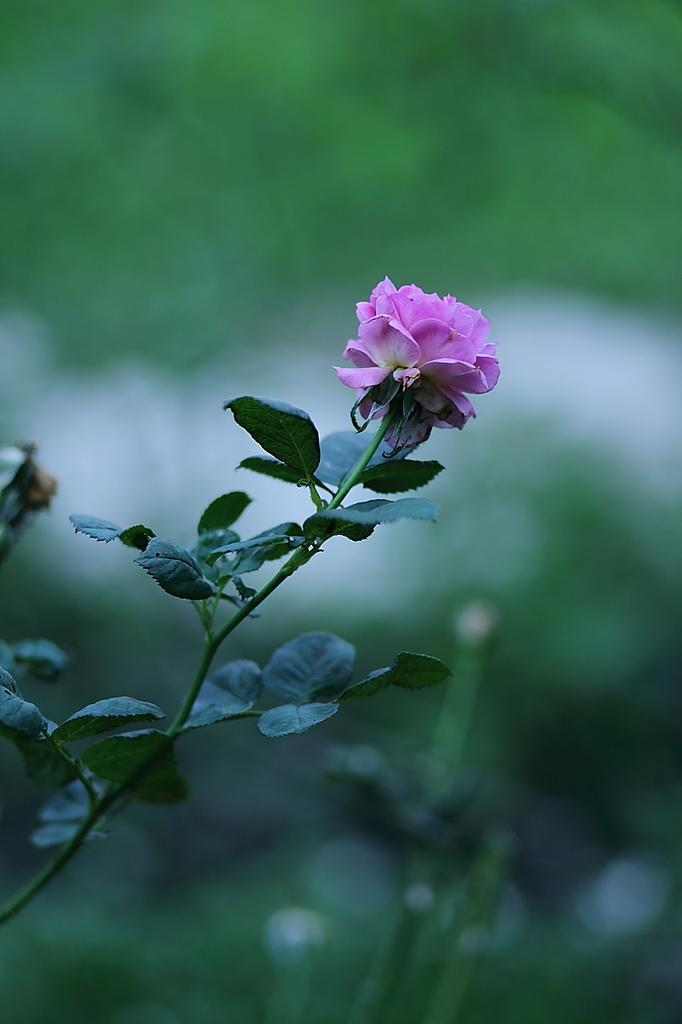What is the main subject of the image? The main subject of the image is a stem with leaves and a flower. Can you describe the flower on the stem? Yes, there is a flower on the stem. What color is the background of the image? The background of the image is green. How many light bulbs are hanging from the rod in the image? There are no light bulbs or rods present in the image; it features a stem with leaves and a flower against a green background. 